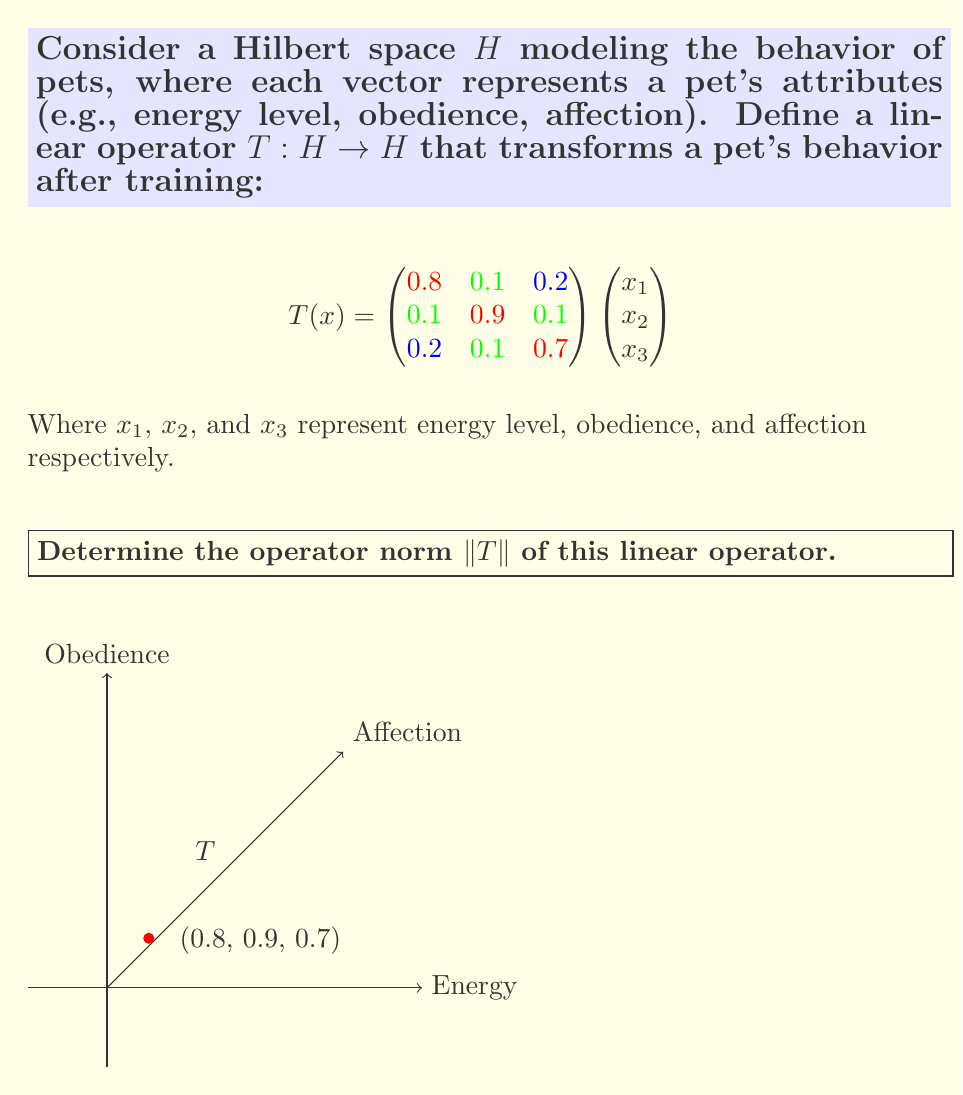Could you help me with this problem? To find the operator norm of $T$, we follow these steps:

1) The operator norm is defined as:
   $$\|T\| = \sup_{x \neq 0} \frac{\|Tx\|}{\|x\|} = \sqrt{\lambda_{\text{max}}}$$
   where $\lambda_{\text{max}}$ is the largest eigenvalue of $T^*T$.

2) First, we need to find $T^*$, the adjoint of $T$. Since $T$ is represented by a real matrix, $T^*$ is simply the transpose of $T$:
   $$T^* = \begin{pmatrix}
   0.8 & 0.1 & 0.2 \\
   0.1 & 0.9 & 0.1 \\
   0.2 & 0.1 & 0.7
   \end{pmatrix}$$

3) Now we compute $T^*T$:
   $$T^*T = \begin{pmatrix}
   0.68 & 0.17 & 0.30 \\
   0.17 & 0.83 & 0.16 \\
   0.30 & 0.16 & 0.54
   \end{pmatrix}$$

4) To find the eigenvalues of $T^*T$, we solve the characteristic equation:
   $$\det(T^*T - \lambda I) = 0$$

5) This gives us the cubic equation:
   $$-\lambda^3 + 2.05\lambda^2 - 1.3975\lambda + 0.3149 = 0$$

6) Solving this equation (using numerical methods or a computer algebra system), we get the eigenvalues:
   $$\lambda_1 \approx 1.0011, \lambda_2 \approx 0.8289, \lambda_3 \approx 0.2200$$

7) The largest eigenvalue is $\lambda_{\text{max}} \approx 1.0011$.

8) Therefore, the operator norm is:
   $$\|T\| = \sqrt{\lambda_{\text{max}}} \approx \sqrt{1.0011} \approx 1.0005$$
Answer: $\|T\| \approx 1.0005$ 